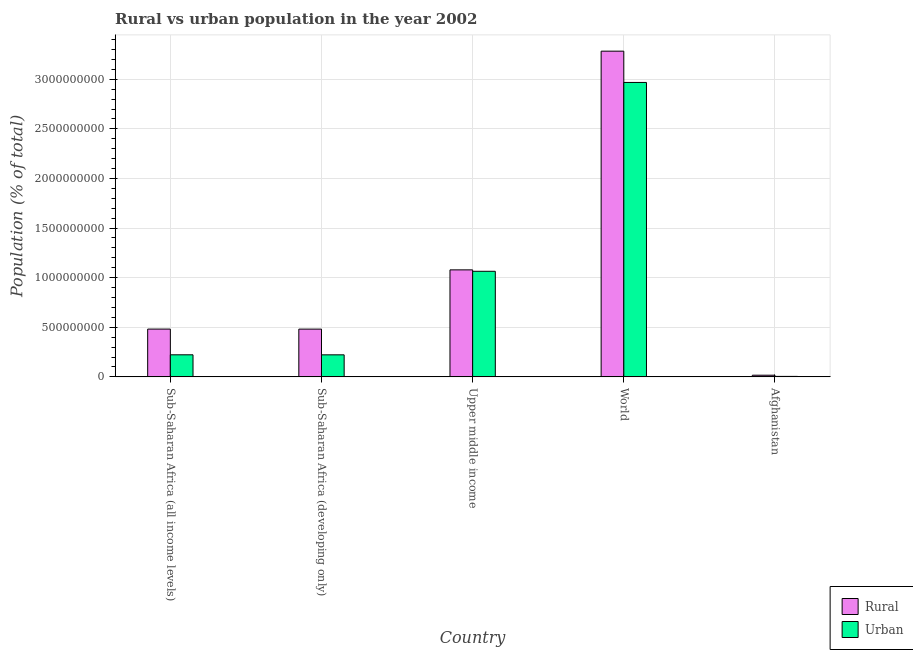How many different coloured bars are there?
Your response must be concise. 2. Are the number of bars on each tick of the X-axis equal?
Provide a short and direct response. Yes. How many bars are there on the 5th tick from the left?
Your answer should be very brief. 2. What is the label of the 4th group of bars from the left?
Your answer should be very brief. World. What is the rural population density in World?
Keep it short and to the point. 3.28e+09. Across all countries, what is the maximum urban population density?
Provide a short and direct response. 2.97e+09. Across all countries, what is the minimum rural population density?
Ensure brevity in your answer.  1.68e+07. In which country was the rural population density maximum?
Your answer should be compact. World. In which country was the urban population density minimum?
Offer a very short reply. Afghanistan. What is the total urban population density in the graph?
Provide a short and direct response. 4.48e+09. What is the difference between the urban population density in Sub-Saharan Africa (developing only) and that in Upper middle income?
Your response must be concise. -8.42e+08. What is the difference between the urban population density in Afghanistan and the rural population density in Upper middle income?
Offer a terse response. -1.07e+09. What is the average rural population density per country?
Your answer should be compact. 1.07e+09. What is the difference between the urban population density and rural population density in Sub-Saharan Africa (developing only)?
Your answer should be very brief. -2.59e+08. In how many countries, is the rural population density greater than 2400000000 %?
Keep it short and to the point. 1. What is the ratio of the rural population density in Sub-Saharan Africa (all income levels) to that in Sub-Saharan Africa (developing only)?
Offer a very short reply. 1. Is the urban population density in Afghanistan less than that in Sub-Saharan Africa (developing only)?
Your answer should be very brief. Yes. What is the difference between the highest and the second highest urban population density?
Offer a terse response. 1.90e+09. What is the difference between the highest and the lowest rural population density?
Provide a short and direct response. 3.27e+09. What does the 1st bar from the left in Sub-Saharan Africa (all income levels) represents?
Keep it short and to the point. Rural. What does the 2nd bar from the right in Sub-Saharan Africa (developing only) represents?
Make the answer very short. Rural. How many bars are there?
Offer a terse response. 10. Are all the bars in the graph horizontal?
Your response must be concise. No. How many countries are there in the graph?
Provide a succinct answer. 5. What is the difference between two consecutive major ticks on the Y-axis?
Ensure brevity in your answer.  5.00e+08. Are the values on the major ticks of Y-axis written in scientific E-notation?
Offer a terse response. No. Does the graph contain grids?
Provide a short and direct response. Yes. Where does the legend appear in the graph?
Offer a very short reply. Bottom right. How are the legend labels stacked?
Give a very brief answer. Vertical. What is the title of the graph?
Offer a terse response. Rural vs urban population in the year 2002. Does "Nitrous oxide emissions" appear as one of the legend labels in the graph?
Provide a short and direct response. No. What is the label or title of the Y-axis?
Offer a terse response. Population (% of total). What is the Population (% of total) in Rural in Sub-Saharan Africa (all income levels)?
Your answer should be very brief. 4.82e+08. What is the Population (% of total) of Urban in Sub-Saharan Africa (all income levels)?
Your response must be concise. 2.22e+08. What is the Population (% of total) of Rural in Sub-Saharan Africa (developing only)?
Provide a short and direct response. 4.81e+08. What is the Population (% of total) in Urban in Sub-Saharan Africa (developing only)?
Your answer should be compact. 2.22e+08. What is the Population (% of total) in Rural in Upper middle income?
Give a very brief answer. 1.08e+09. What is the Population (% of total) in Urban in Upper middle income?
Provide a succinct answer. 1.06e+09. What is the Population (% of total) in Rural in World?
Ensure brevity in your answer.  3.28e+09. What is the Population (% of total) of Urban in World?
Your response must be concise. 2.97e+09. What is the Population (% of total) in Rural in Afghanistan?
Offer a terse response. 1.68e+07. What is the Population (% of total) in Urban in Afghanistan?
Make the answer very short. 4.71e+06. Across all countries, what is the maximum Population (% of total) of Rural?
Provide a succinct answer. 3.28e+09. Across all countries, what is the maximum Population (% of total) in Urban?
Your answer should be very brief. 2.97e+09. Across all countries, what is the minimum Population (% of total) of Rural?
Ensure brevity in your answer.  1.68e+07. Across all countries, what is the minimum Population (% of total) of Urban?
Provide a succinct answer. 4.71e+06. What is the total Population (% of total) in Rural in the graph?
Provide a succinct answer. 5.34e+09. What is the total Population (% of total) in Urban in the graph?
Provide a short and direct response. 4.48e+09. What is the difference between the Population (% of total) of Rural in Sub-Saharan Africa (all income levels) and that in Sub-Saharan Africa (developing only)?
Your answer should be compact. 3.89e+05. What is the difference between the Population (% of total) in Urban in Sub-Saharan Africa (all income levels) and that in Sub-Saharan Africa (developing only)?
Your answer should be compact. 2.62e+05. What is the difference between the Population (% of total) of Rural in Sub-Saharan Africa (all income levels) and that in Upper middle income?
Make the answer very short. -5.97e+08. What is the difference between the Population (% of total) of Urban in Sub-Saharan Africa (all income levels) and that in Upper middle income?
Offer a very short reply. -8.42e+08. What is the difference between the Population (% of total) in Rural in Sub-Saharan Africa (all income levels) and that in World?
Keep it short and to the point. -2.80e+09. What is the difference between the Population (% of total) of Urban in Sub-Saharan Africa (all income levels) and that in World?
Offer a very short reply. -2.75e+09. What is the difference between the Population (% of total) of Rural in Sub-Saharan Africa (all income levels) and that in Afghanistan?
Provide a succinct answer. 4.65e+08. What is the difference between the Population (% of total) of Urban in Sub-Saharan Africa (all income levels) and that in Afghanistan?
Offer a very short reply. 2.18e+08. What is the difference between the Population (% of total) in Rural in Sub-Saharan Africa (developing only) and that in Upper middle income?
Provide a succinct answer. -5.97e+08. What is the difference between the Population (% of total) in Urban in Sub-Saharan Africa (developing only) and that in Upper middle income?
Your answer should be very brief. -8.42e+08. What is the difference between the Population (% of total) of Rural in Sub-Saharan Africa (developing only) and that in World?
Provide a succinct answer. -2.80e+09. What is the difference between the Population (% of total) of Urban in Sub-Saharan Africa (developing only) and that in World?
Your response must be concise. -2.75e+09. What is the difference between the Population (% of total) in Rural in Sub-Saharan Africa (developing only) and that in Afghanistan?
Your answer should be very brief. 4.65e+08. What is the difference between the Population (% of total) of Urban in Sub-Saharan Africa (developing only) and that in Afghanistan?
Ensure brevity in your answer.  2.17e+08. What is the difference between the Population (% of total) of Rural in Upper middle income and that in World?
Your answer should be very brief. -2.20e+09. What is the difference between the Population (% of total) in Urban in Upper middle income and that in World?
Make the answer very short. -1.90e+09. What is the difference between the Population (% of total) in Rural in Upper middle income and that in Afghanistan?
Keep it short and to the point. 1.06e+09. What is the difference between the Population (% of total) in Urban in Upper middle income and that in Afghanistan?
Your answer should be very brief. 1.06e+09. What is the difference between the Population (% of total) in Rural in World and that in Afghanistan?
Offer a very short reply. 3.27e+09. What is the difference between the Population (% of total) of Urban in World and that in Afghanistan?
Provide a succinct answer. 2.96e+09. What is the difference between the Population (% of total) of Rural in Sub-Saharan Africa (all income levels) and the Population (% of total) of Urban in Sub-Saharan Africa (developing only)?
Your response must be concise. 2.60e+08. What is the difference between the Population (% of total) of Rural in Sub-Saharan Africa (all income levels) and the Population (% of total) of Urban in Upper middle income?
Give a very brief answer. -5.83e+08. What is the difference between the Population (% of total) in Rural in Sub-Saharan Africa (all income levels) and the Population (% of total) in Urban in World?
Provide a short and direct response. -2.49e+09. What is the difference between the Population (% of total) of Rural in Sub-Saharan Africa (all income levels) and the Population (% of total) of Urban in Afghanistan?
Your answer should be very brief. 4.77e+08. What is the difference between the Population (% of total) of Rural in Sub-Saharan Africa (developing only) and the Population (% of total) of Urban in Upper middle income?
Provide a succinct answer. -5.83e+08. What is the difference between the Population (% of total) in Rural in Sub-Saharan Africa (developing only) and the Population (% of total) in Urban in World?
Provide a short and direct response. -2.49e+09. What is the difference between the Population (% of total) in Rural in Sub-Saharan Africa (developing only) and the Population (% of total) in Urban in Afghanistan?
Offer a very short reply. 4.77e+08. What is the difference between the Population (% of total) of Rural in Upper middle income and the Population (% of total) of Urban in World?
Give a very brief answer. -1.89e+09. What is the difference between the Population (% of total) of Rural in Upper middle income and the Population (% of total) of Urban in Afghanistan?
Provide a short and direct response. 1.07e+09. What is the difference between the Population (% of total) in Rural in World and the Population (% of total) in Urban in Afghanistan?
Your answer should be compact. 3.28e+09. What is the average Population (% of total) of Rural per country?
Give a very brief answer. 1.07e+09. What is the average Population (% of total) of Urban per country?
Give a very brief answer. 8.96e+08. What is the difference between the Population (% of total) in Rural and Population (% of total) in Urban in Sub-Saharan Africa (all income levels)?
Your response must be concise. 2.59e+08. What is the difference between the Population (% of total) of Rural and Population (% of total) of Urban in Sub-Saharan Africa (developing only)?
Keep it short and to the point. 2.59e+08. What is the difference between the Population (% of total) in Rural and Population (% of total) in Urban in Upper middle income?
Give a very brief answer. 1.43e+07. What is the difference between the Population (% of total) of Rural and Population (% of total) of Urban in World?
Provide a short and direct response. 3.15e+08. What is the difference between the Population (% of total) of Rural and Population (% of total) of Urban in Afghanistan?
Your response must be concise. 1.21e+07. What is the ratio of the Population (% of total) of Urban in Sub-Saharan Africa (all income levels) to that in Sub-Saharan Africa (developing only)?
Offer a terse response. 1. What is the ratio of the Population (% of total) in Rural in Sub-Saharan Africa (all income levels) to that in Upper middle income?
Make the answer very short. 0.45. What is the ratio of the Population (% of total) of Urban in Sub-Saharan Africa (all income levels) to that in Upper middle income?
Give a very brief answer. 0.21. What is the ratio of the Population (% of total) in Rural in Sub-Saharan Africa (all income levels) to that in World?
Make the answer very short. 0.15. What is the ratio of the Population (% of total) of Urban in Sub-Saharan Africa (all income levels) to that in World?
Keep it short and to the point. 0.07. What is the ratio of the Population (% of total) of Rural in Sub-Saharan Africa (all income levels) to that in Afghanistan?
Give a very brief answer. 28.71. What is the ratio of the Population (% of total) of Urban in Sub-Saharan Africa (all income levels) to that in Afghanistan?
Keep it short and to the point. 47.24. What is the ratio of the Population (% of total) in Rural in Sub-Saharan Africa (developing only) to that in Upper middle income?
Your answer should be compact. 0.45. What is the ratio of the Population (% of total) in Urban in Sub-Saharan Africa (developing only) to that in Upper middle income?
Ensure brevity in your answer.  0.21. What is the ratio of the Population (% of total) in Rural in Sub-Saharan Africa (developing only) to that in World?
Your answer should be compact. 0.15. What is the ratio of the Population (% of total) in Urban in Sub-Saharan Africa (developing only) to that in World?
Keep it short and to the point. 0.07. What is the ratio of the Population (% of total) in Rural in Sub-Saharan Africa (developing only) to that in Afghanistan?
Ensure brevity in your answer.  28.69. What is the ratio of the Population (% of total) in Urban in Sub-Saharan Africa (developing only) to that in Afghanistan?
Your response must be concise. 47.18. What is the ratio of the Population (% of total) in Rural in Upper middle income to that in World?
Give a very brief answer. 0.33. What is the ratio of the Population (% of total) in Urban in Upper middle income to that in World?
Make the answer very short. 0.36. What is the ratio of the Population (% of total) of Rural in Upper middle income to that in Afghanistan?
Provide a succinct answer. 64.28. What is the ratio of the Population (% of total) of Urban in Upper middle income to that in Afghanistan?
Keep it short and to the point. 226. What is the ratio of the Population (% of total) of Rural in World to that in Afghanistan?
Keep it short and to the point. 195.67. What is the ratio of the Population (% of total) in Urban in World to that in Afghanistan?
Ensure brevity in your answer.  630.24. What is the difference between the highest and the second highest Population (% of total) in Rural?
Ensure brevity in your answer.  2.20e+09. What is the difference between the highest and the second highest Population (% of total) in Urban?
Keep it short and to the point. 1.90e+09. What is the difference between the highest and the lowest Population (% of total) in Rural?
Your answer should be very brief. 3.27e+09. What is the difference between the highest and the lowest Population (% of total) of Urban?
Ensure brevity in your answer.  2.96e+09. 